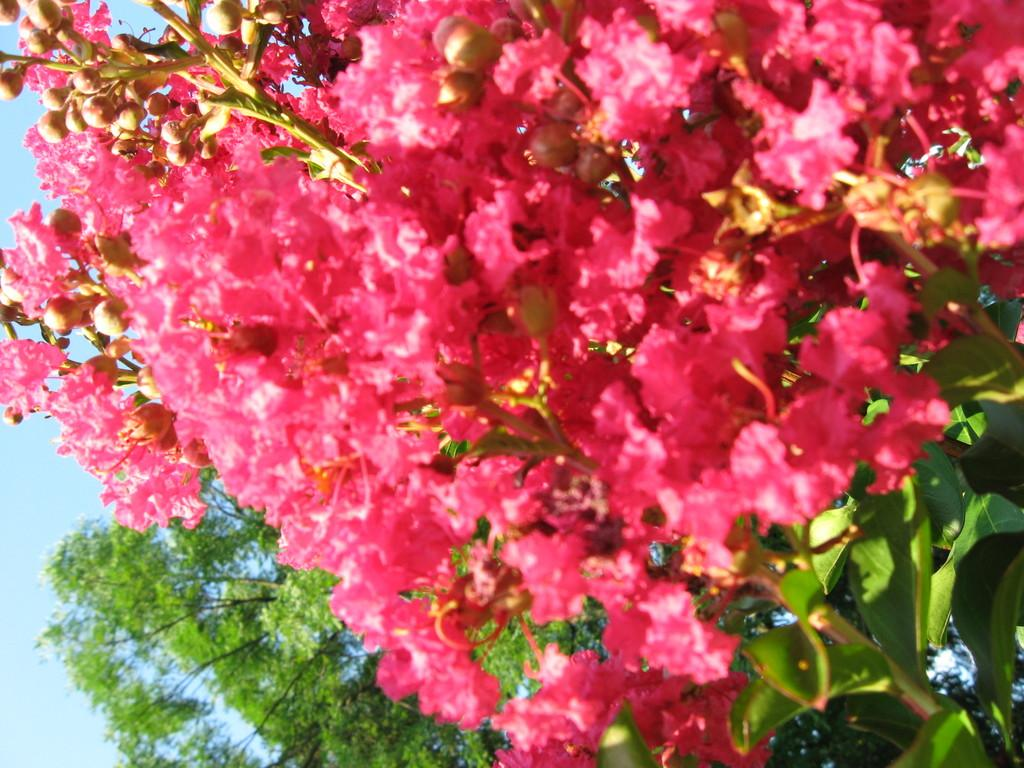What type of plants are in the image? The plants in the image have flowers on them. What color are the flowers on the plants? The flowers on the plants are pink in color. What stage of growth are the flowers on the plants in? There are buds on the plants in the image, indicating that they are in the process of blooming. What can be seen in the background of the image? The sky is visible in the background of the image. What type of wire is used to support the flowers in the image? There is no wire present in the image; the flowers are growing on plants. 